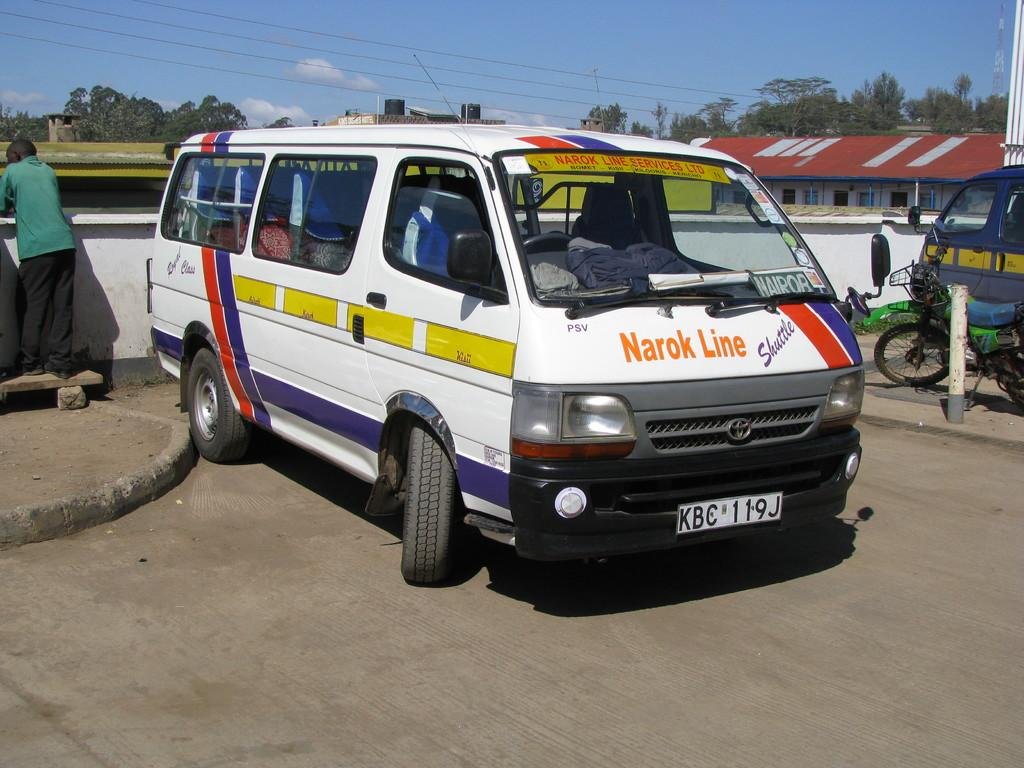<image>
Offer a succinct explanation of the picture presented. A white van with Narok Line printed on its hood. 